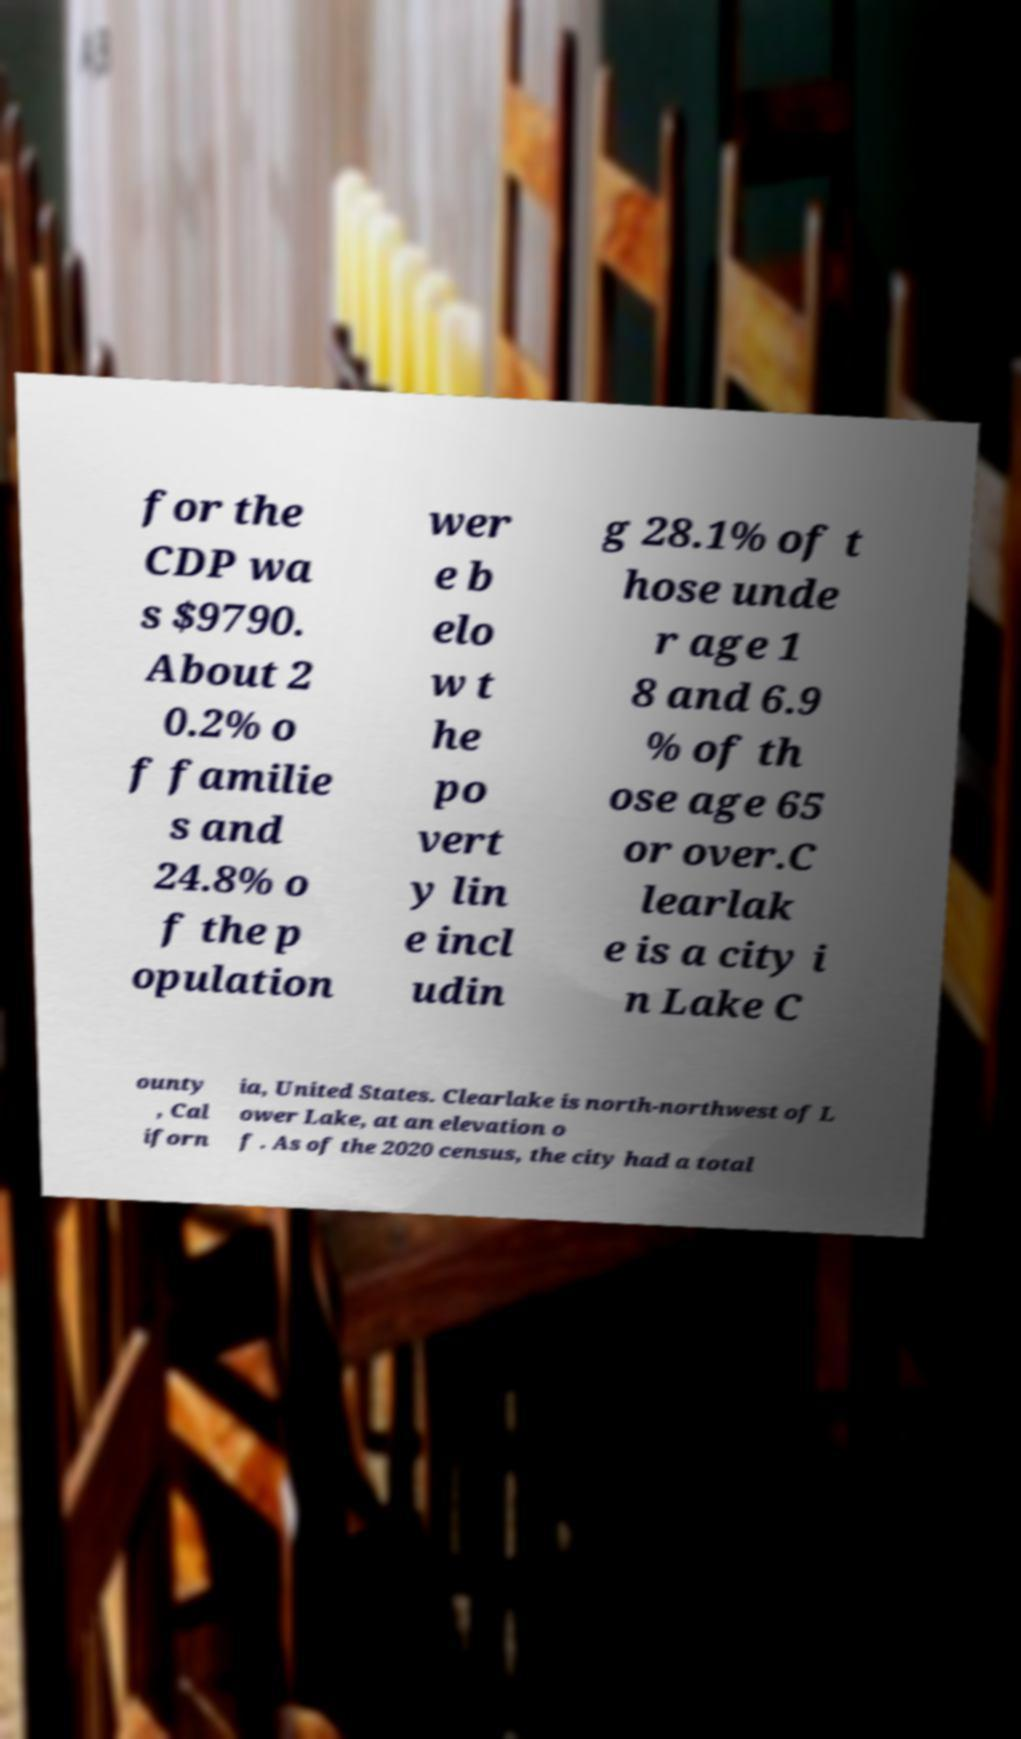There's text embedded in this image that I need extracted. Can you transcribe it verbatim? for the CDP wa s $9790. About 2 0.2% o f familie s and 24.8% o f the p opulation wer e b elo w t he po vert y lin e incl udin g 28.1% of t hose unde r age 1 8 and 6.9 % of th ose age 65 or over.C learlak e is a city i n Lake C ounty , Cal iforn ia, United States. Clearlake is north-northwest of L ower Lake, at an elevation o f . As of the 2020 census, the city had a total 